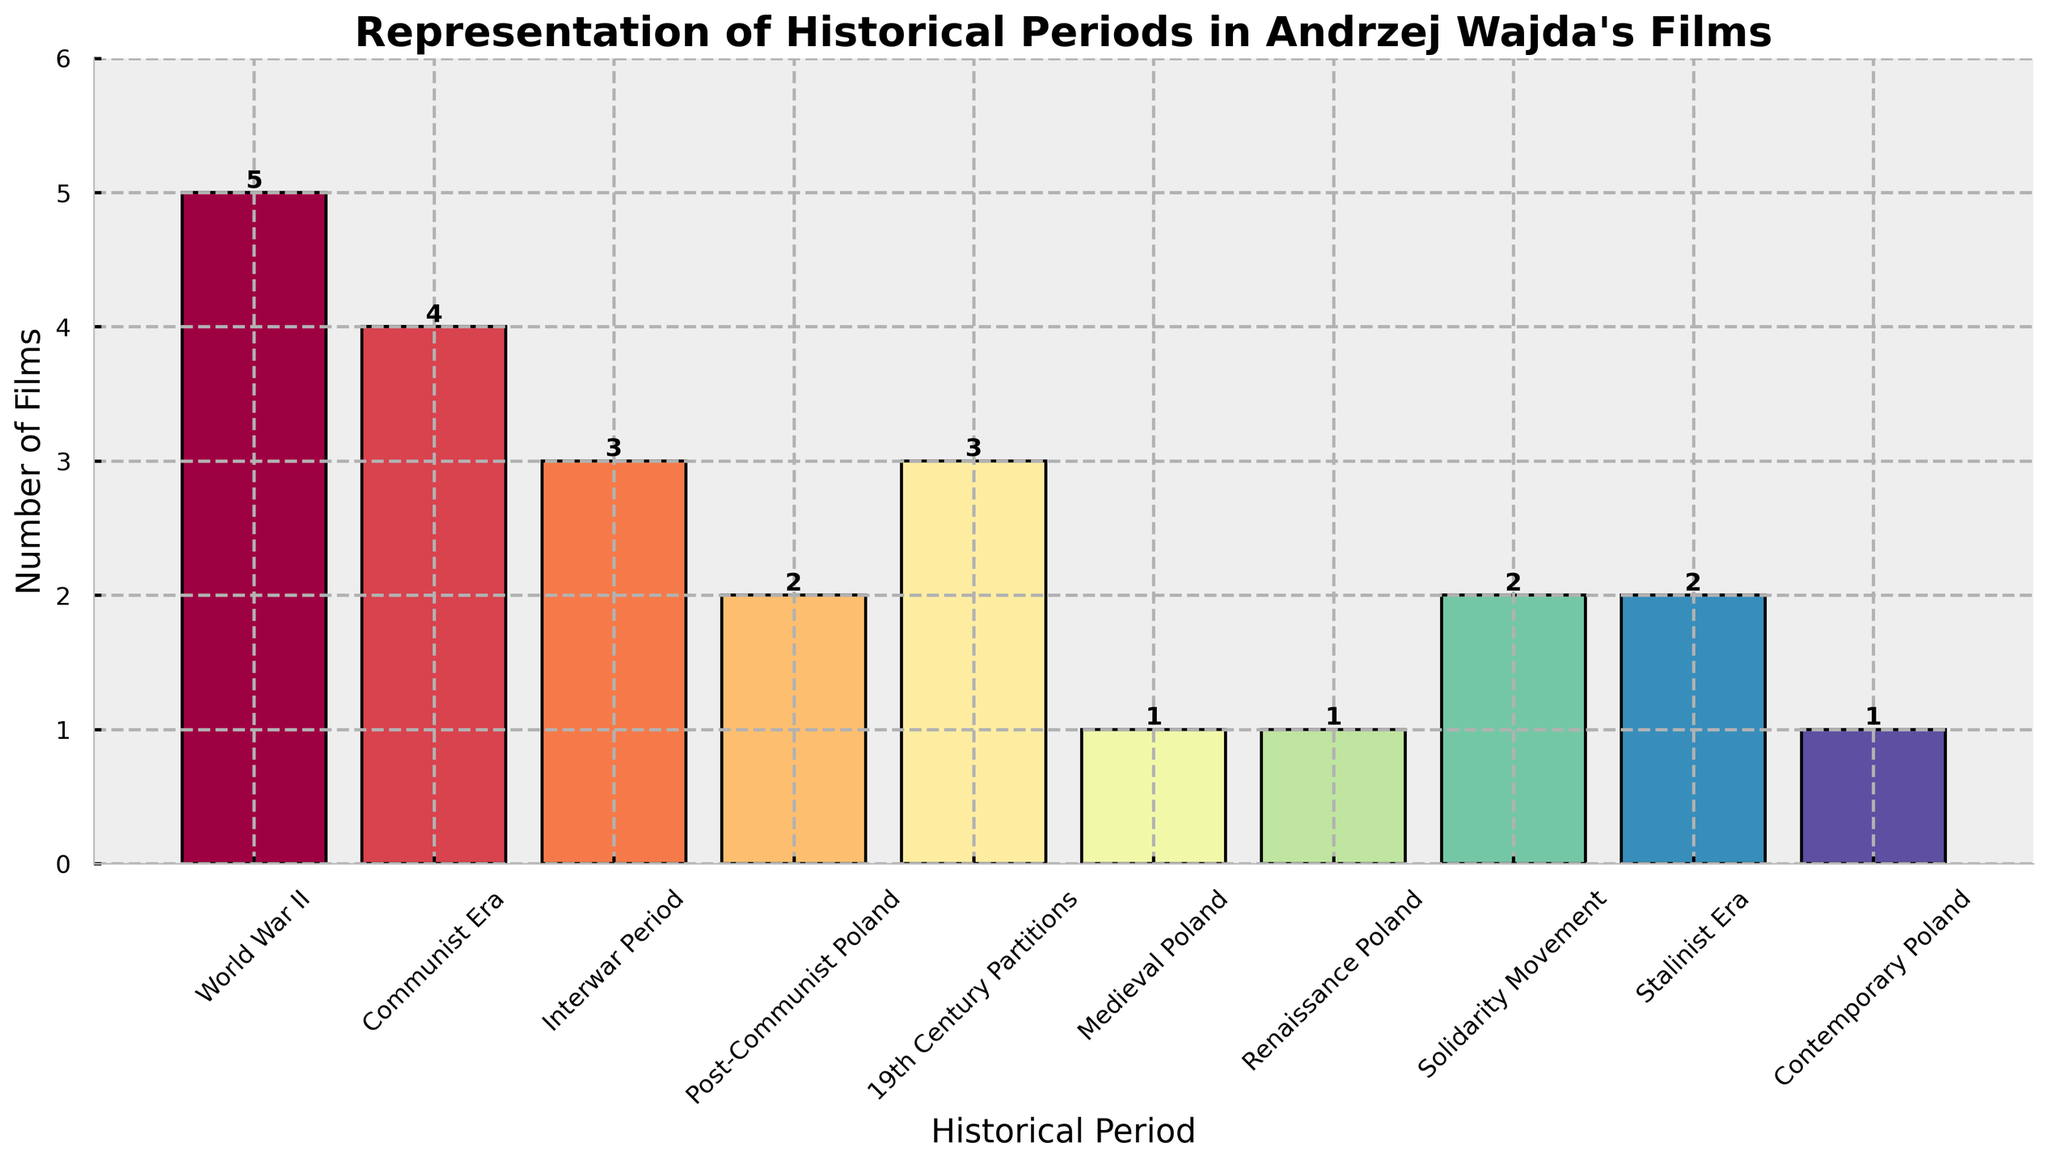What historical period has the highest number of films depicted by Andrzej Wajda? The bar representing "World War II" is the tallest among all the bars, indicating it has the highest number of films.
Answer: World War II Which historical periods are equally represented with the same number of films in Andrzej Wajda's work? By comparing the heights of the bars, we see that "Interwar Period" and "19th Century Partitions" both have the same height, indicating they have the same number of films.
Answer: Interwar Period and 19th Century Partitions How many more films are there about World War II than about the Medieval period? The bar for "World War II" represents 5 films while the bar for "Medieval Poland" represents 1 film, so the difference is 5 - 1.
Answer: 4 What is the total number of films depicted in the Communist Era, Stalinist Era, and Solidarity Movement combined? Adding the heights of the bars, we get 4 (Communist Era) + 2 (Stalinist Era) + 2 (Solidarity Movement) = 8.
Answer: 8 Which historical period with a single film depicted is least recent? Among the periods with a single film depicted ("Medieval Poland," "Renaissance Poland," and "Contemporary Poland"), "Medieval Poland" is the least recent.
Answer: Medieval Poland What fraction of the films are set in Post-Communist Poland? There are 20 films in total. The number of films set in Post-Communist Poland is 2. Thus the fraction is 2/20 or 1/10.
Answer: 1/10 How does the representation of the Communist Era compare to the Interwar Period in Andrzej Wajda's films? The bar for the Communist Era represents 4 films while the bar for the Interwar Period represents 3 films.
Answer: The Communist Era has 1 more film Which periods are represented by exactly two films each? By comparing the heights of the bars, we see that "Post-Communist Poland," "Solidarity Movement," and "Stalinist Era" each represent 2 films.
Answer: Post-Communist Poland, Solidarity Movement, and Stalinist Era What is the difference in the number of films between the most and least depicted historical periods? The most depicted period is "World War II" with 5 films, and the least depicted are "Medieval Poland," "Renaissance Poland," and "Contemporary Poland," each with 1 film. The difference is 5 - 1.
Answer: 4 